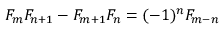Convert formula to latex. <formula><loc_0><loc_0><loc_500><loc_500>F _ { m } F _ { n + 1 } - F _ { m + 1 } F _ { n } = ( - 1 ) ^ { n } F _ { m - n }</formula> 